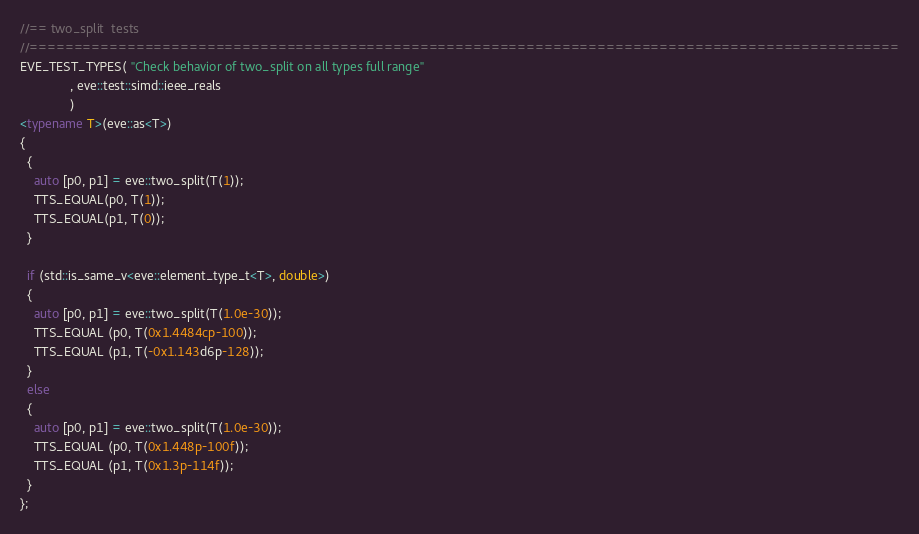<code> <loc_0><loc_0><loc_500><loc_500><_C++_>//== two_split  tests
//==================================================================================================
EVE_TEST_TYPES( "Check behavior of two_split on all types full range"
              , eve::test::simd::ieee_reals
              )
<typename T>(eve::as<T>)
{
  {
    auto [p0, p1] = eve::two_split(T(1));
    TTS_EQUAL(p0, T(1));
    TTS_EQUAL(p1, T(0));
  }

  if (std::is_same_v<eve::element_type_t<T>, double>)
  {
    auto [p0, p1] = eve::two_split(T(1.0e-30));
    TTS_EQUAL (p0, T(0x1.4484cp-100));
    TTS_EQUAL (p1, T(-0x1.143d6p-128));
  }
  else
  {
    auto [p0, p1] = eve::two_split(T(1.0e-30));
    TTS_EQUAL (p0, T(0x1.448p-100f));
    TTS_EQUAL (p1, T(0x1.3p-114f));
  }
};
</code> 